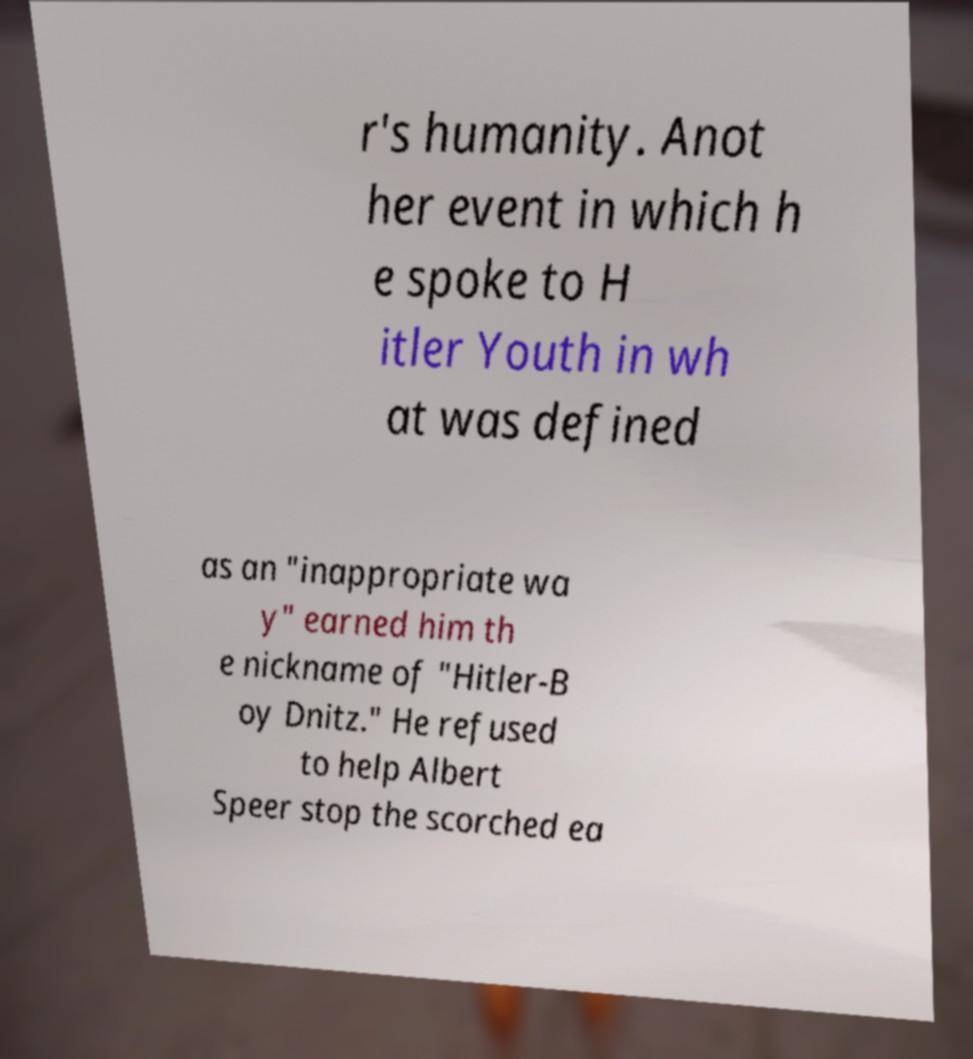Could you assist in decoding the text presented in this image and type it out clearly? r's humanity. Anot her event in which h e spoke to H itler Youth in wh at was defined as an "inappropriate wa y" earned him th e nickname of "Hitler-B oy Dnitz." He refused to help Albert Speer stop the scorched ea 